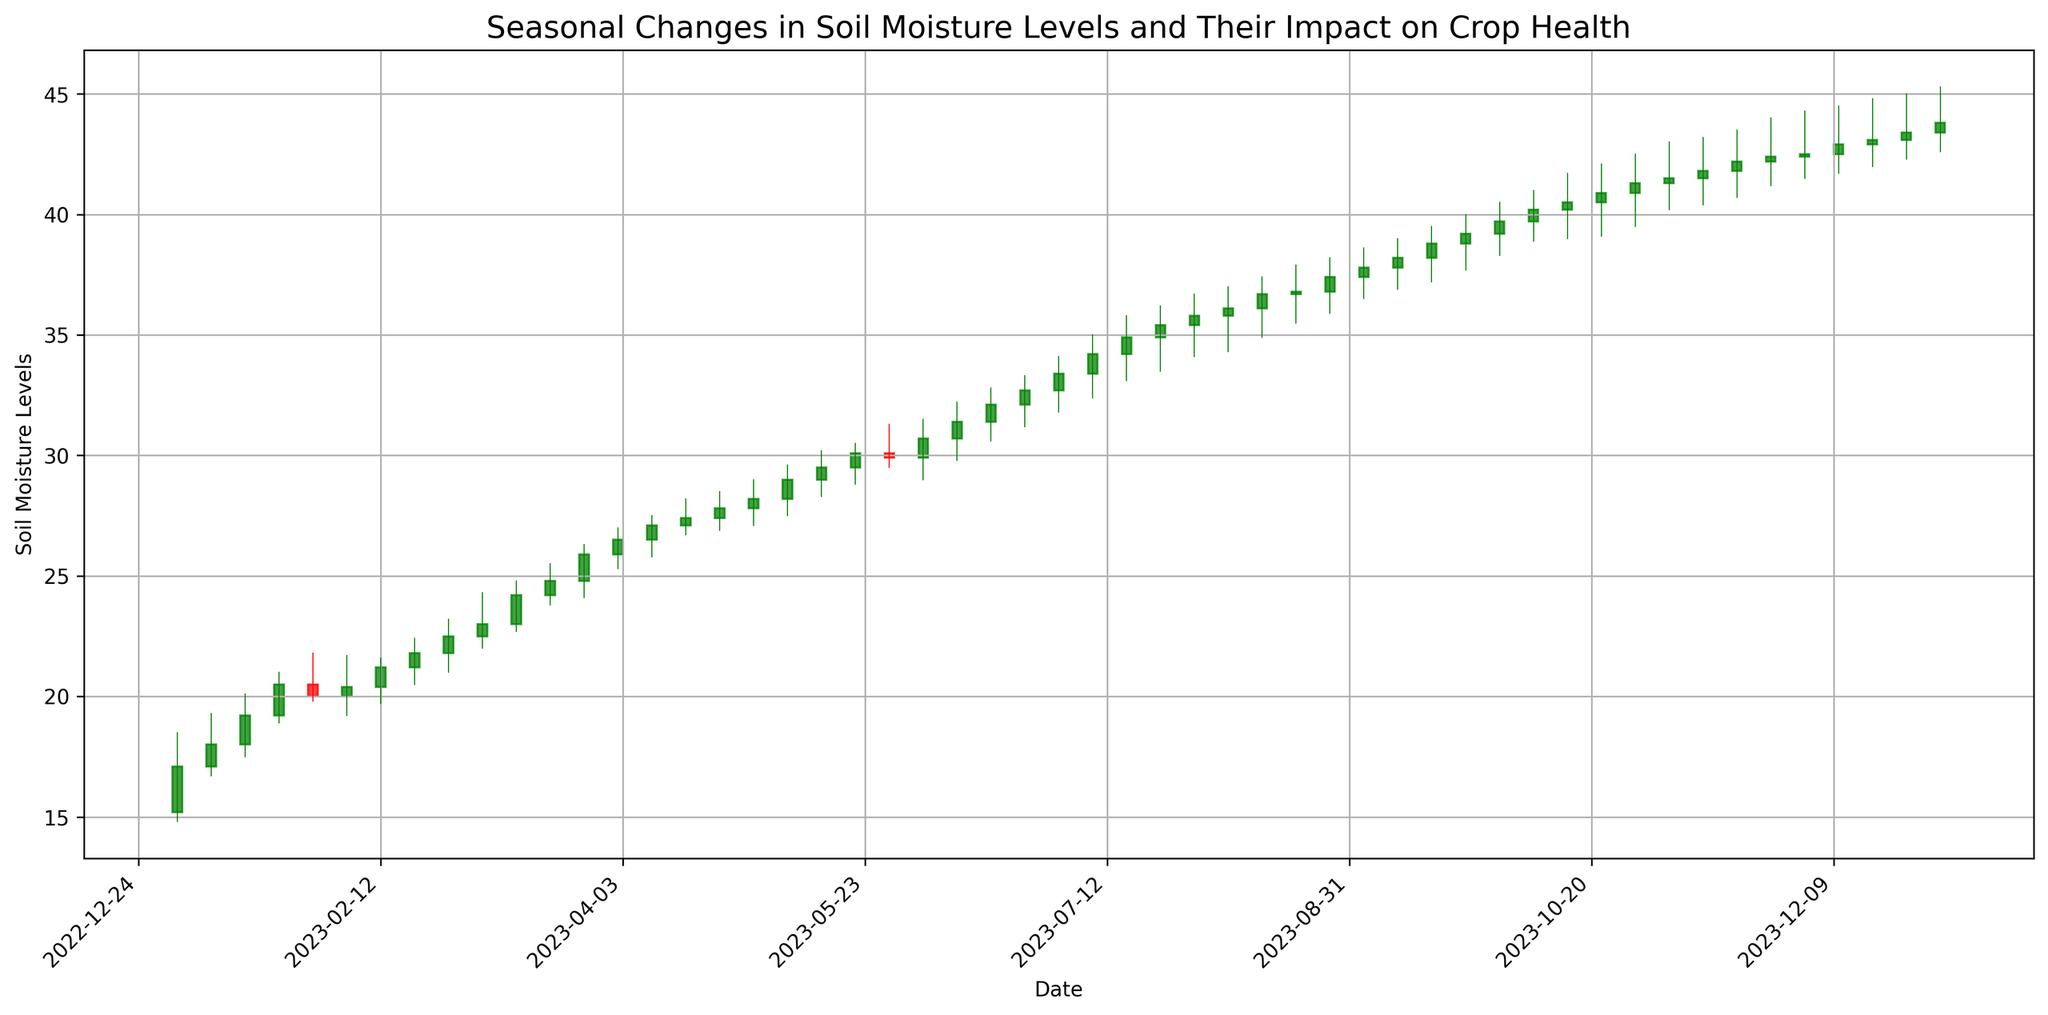What is the overall trend in soil moisture levels from January to December? The overall trend can be observed by looking at the "Close" values on the candlestick chart from the start (January) to the end (December). The "Close" values generally increase from around 17.1 to 43.8 by the end of the year.
Answer: Increasing During which month do we observe the highest single-week increase in soil moisture levels? By examining the candlesticks, the highest single-week increase can be noticed by comparing the difference between the "Close" value of the current week and the "Open" value of the same week. The largest increase is in April when the "Close" went from around 26.5 to 27.1 on April 9.
Answer: April In which quarter do soil moisture levels show the most growth? Quarters are divided as Q1 (Jan-Mar), Q2 (Apr-Jun), Q3 (Jul-Sep), and Q4 (Oct-Dec). By comparing the "Close" values at the start and end of each quarter, we see: Q1: 17.1 to 24.8, Q2: 25.9 to 32.1, Q3: 32.7 to 38.8, Q4: 39.2 to 43.8. Q4 shows the most growth.
Answer: Q4 Which month shows the greatest fluctuation in soil moisture levels? Fluctuations within a month can be identified by the highest difference between the "High" and "Low" values. Looking at the candlesticks, the month of July shows some of the largest fluctuations, indicating broad ranges in the "High" and "Low" values.
Answer: July How does the soil moisture level on October 01 compare with the level on June 01? To compare the soil moisture levels, check the "Close" value on October 01 and June 01. On October 01, the "Close" value is around 39.7, while on June 01, it is around 30.7. Therefore, the soil moisture level is higher on October 01.
Answer: Higher on October 01 